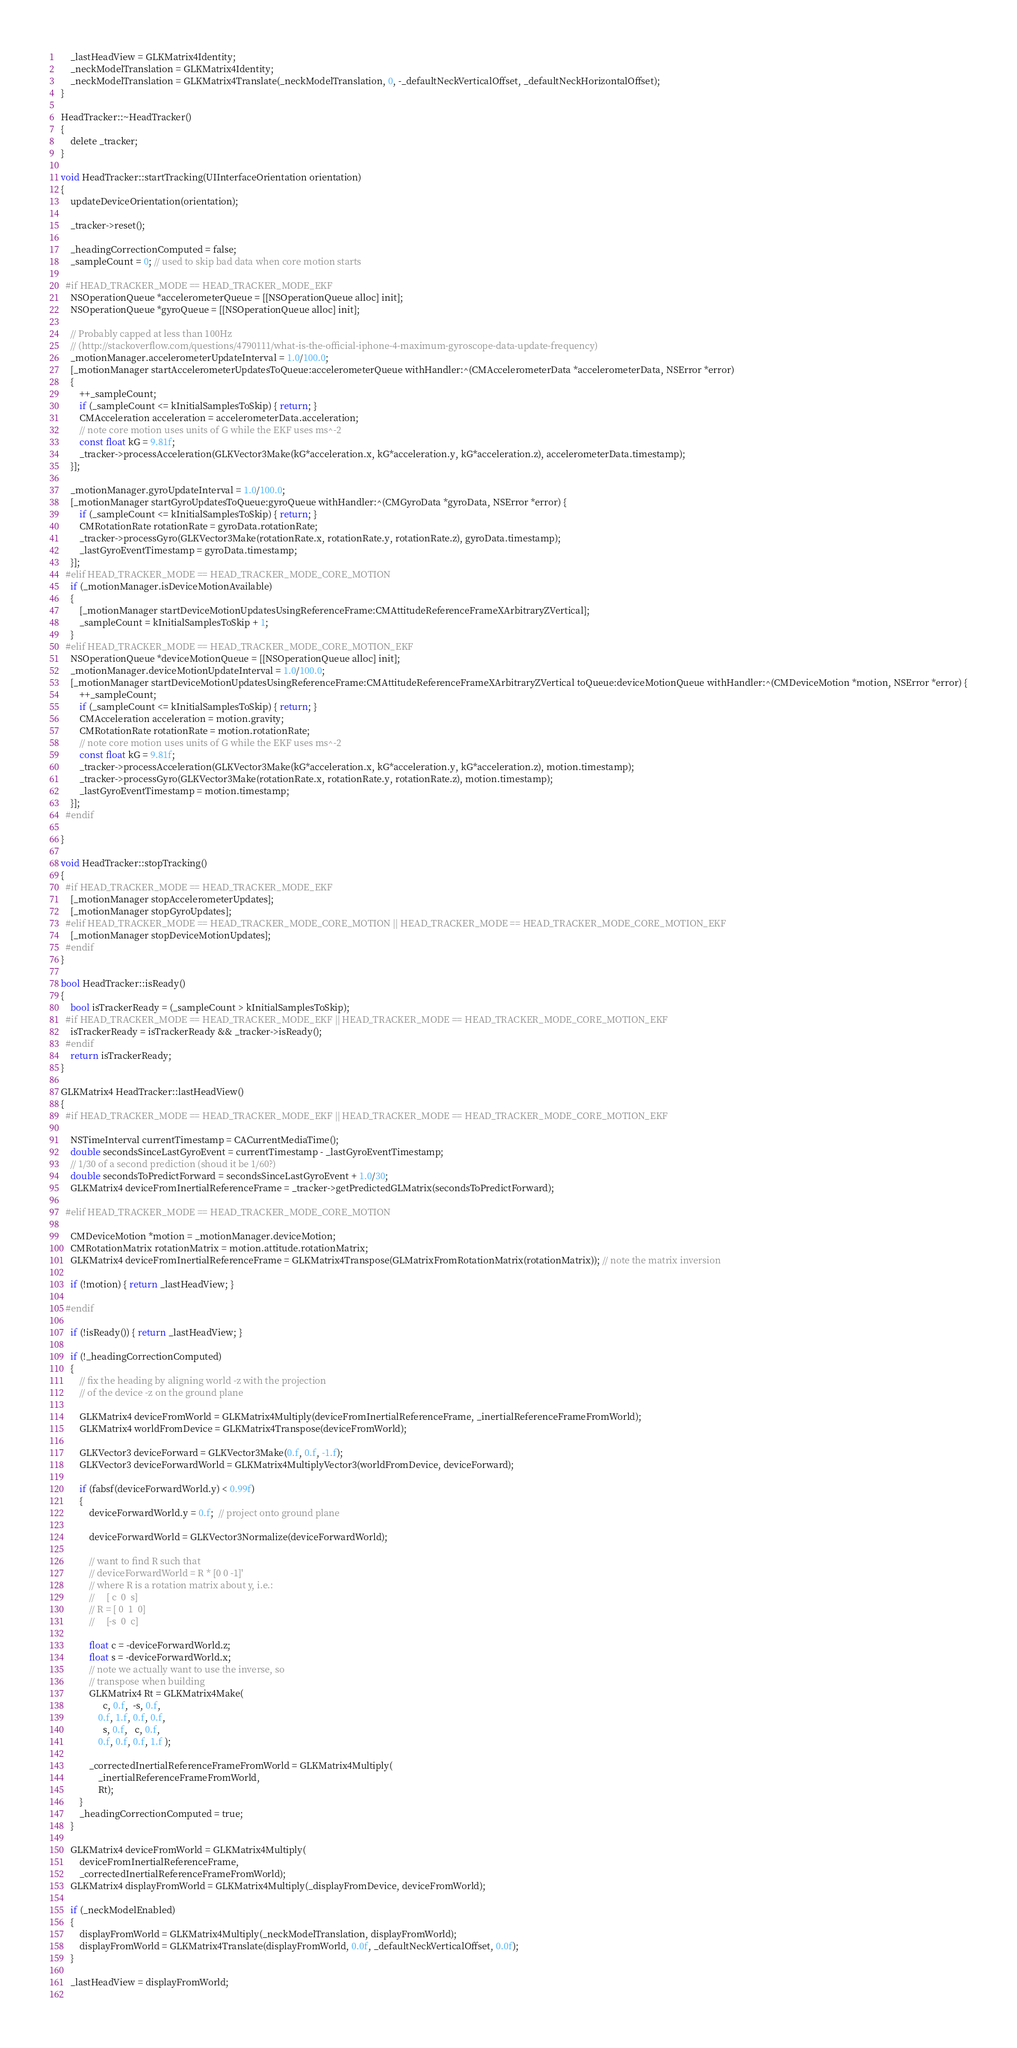Convert code to text. <code><loc_0><loc_0><loc_500><loc_500><_ObjectiveC_>    _lastHeadView = GLKMatrix4Identity;
    _neckModelTranslation = GLKMatrix4Identity;
    _neckModelTranslation = GLKMatrix4Translate(_neckModelTranslation, 0, -_defaultNeckVerticalOffset, _defaultNeckHorizontalOffset);
}

HeadTracker::~HeadTracker()
{
    delete _tracker;
}

void HeadTracker::startTracking(UIInterfaceOrientation orientation)
{
    updateDeviceOrientation(orientation);
    
    _tracker->reset();
    
    _headingCorrectionComputed = false;
    _sampleCount = 0; // used to skip bad data when core motion starts
    
  #if HEAD_TRACKER_MODE == HEAD_TRACKER_MODE_EKF
    NSOperationQueue *accelerometerQueue = [[NSOperationQueue alloc] init];
    NSOperationQueue *gyroQueue = [[NSOperationQueue alloc] init];
    
    // Probably capped at less than 100Hz
    // (http://stackoverflow.com/questions/4790111/what-is-the-official-iphone-4-maximum-gyroscope-data-update-frequency)
    _motionManager.accelerometerUpdateInterval = 1.0/100.0;
    [_motionManager startAccelerometerUpdatesToQueue:accelerometerQueue withHandler:^(CMAccelerometerData *accelerometerData, NSError *error)
    {
        ++_sampleCount;
        if (_sampleCount <= kInitialSamplesToSkip) { return; }
        CMAcceleration acceleration = accelerometerData.acceleration;
        // note core motion uses units of G while the EKF uses ms^-2
        const float kG = 9.81f;
        _tracker->processAcceleration(GLKVector3Make(kG*acceleration.x, kG*acceleration.y, kG*acceleration.z), accelerometerData.timestamp);
    }];
    
    _motionManager.gyroUpdateInterval = 1.0/100.0;
    [_motionManager startGyroUpdatesToQueue:gyroQueue withHandler:^(CMGyroData *gyroData, NSError *error) {
        if (_sampleCount <= kInitialSamplesToSkip) { return; }
        CMRotationRate rotationRate = gyroData.rotationRate;
        _tracker->processGyro(GLKVector3Make(rotationRate.x, rotationRate.y, rotationRate.z), gyroData.timestamp);
        _lastGyroEventTimestamp = gyroData.timestamp;
    }];
  #elif HEAD_TRACKER_MODE == HEAD_TRACKER_MODE_CORE_MOTION
    if (_motionManager.isDeviceMotionAvailable)
    {
        [_motionManager startDeviceMotionUpdatesUsingReferenceFrame:CMAttitudeReferenceFrameXArbitraryZVertical];
        _sampleCount = kInitialSamplesToSkip + 1;
    }
  #elif HEAD_TRACKER_MODE == HEAD_TRACKER_MODE_CORE_MOTION_EKF
    NSOperationQueue *deviceMotionQueue = [[NSOperationQueue alloc] init];
    _motionManager.deviceMotionUpdateInterval = 1.0/100.0;
    [_motionManager startDeviceMotionUpdatesUsingReferenceFrame:CMAttitudeReferenceFrameXArbitraryZVertical toQueue:deviceMotionQueue withHandler:^(CMDeviceMotion *motion, NSError *error) {
        ++_sampleCount;
        if (_sampleCount <= kInitialSamplesToSkip) { return; }
        CMAcceleration acceleration = motion.gravity;
        CMRotationRate rotationRate = motion.rotationRate;
        // note core motion uses units of G while the EKF uses ms^-2
        const float kG = 9.81f;
        _tracker->processAcceleration(GLKVector3Make(kG*acceleration.x, kG*acceleration.y, kG*acceleration.z), motion.timestamp);
        _tracker->processGyro(GLKVector3Make(rotationRate.x, rotationRate.y, rotationRate.z), motion.timestamp);
        _lastGyroEventTimestamp = motion.timestamp;
    }];
  #endif
    
}

void HeadTracker::stopTracking()
{
  #if HEAD_TRACKER_MODE == HEAD_TRACKER_MODE_EKF
    [_motionManager stopAccelerometerUpdates];
    [_motionManager stopGyroUpdates];
  #elif HEAD_TRACKER_MODE == HEAD_TRACKER_MODE_CORE_MOTION || HEAD_TRACKER_MODE == HEAD_TRACKER_MODE_CORE_MOTION_EKF
    [_motionManager stopDeviceMotionUpdates];
  #endif
}

bool HeadTracker::isReady()
{
    bool isTrackerReady = (_sampleCount > kInitialSamplesToSkip);
  #if HEAD_TRACKER_MODE == HEAD_TRACKER_MODE_EKF || HEAD_TRACKER_MODE == HEAD_TRACKER_MODE_CORE_MOTION_EKF
    isTrackerReady = isTrackerReady && _tracker->isReady();
  #endif
    return isTrackerReady;
}

GLKMatrix4 HeadTracker::lastHeadView()
{
  #if HEAD_TRACKER_MODE == HEAD_TRACKER_MODE_EKF || HEAD_TRACKER_MODE == HEAD_TRACKER_MODE_CORE_MOTION_EKF
    
    NSTimeInterval currentTimestamp = CACurrentMediaTime();
    double secondsSinceLastGyroEvent = currentTimestamp - _lastGyroEventTimestamp;
    // 1/30 of a second prediction (shoud it be 1/60?)
    double secondsToPredictForward = secondsSinceLastGyroEvent + 1.0/30;
    GLKMatrix4 deviceFromInertialReferenceFrame = _tracker->getPredictedGLMatrix(secondsToPredictForward);
    
  #elif HEAD_TRACKER_MODE == HEAD_TRACKER_MODE_CORE_MOTION
    
    CMDeviceMotion *motion = _motionManager.deviceMotion;
    CMRotationMatrix rotationMatrix = motion.attitude.rotationMatrix;
    GLKMatrix4 deviceFromInertialReferenceFrame = GLKMatrix4Transpose(GLMatrixFromRotationMatrix(rotationMatrix)); // note the matrix inversion
    
    if (!motion) { return _lastHeadView; }
    
  #endif
  
    if (!isReady()) { return _lastHeadView; }

    if (!_headingCorrectionComputed)
    {
        // fix the heading by aligning world -z with the projection 
        // of the device -z on the ground plane
        
        GLKMatrix4 deviceFromWorld = GLKMatrix4Multiply(deviceFromInertialReferenceFrame, _inertialReferenceFrameFromWorld);
        GLKMatrix4 worldFromDevice = GLKMatrix4Transpose(deviceFromWorld);
        
        GLKVector3 deviceForward = GLKVector3Make(0.f, 0.f, -1.f);
        GLKVector3 deviceForwardWorld = GLKMatrix4MultiplyVector3(worldFromDevice, deviceForward);
        
        if (fabsf(deviceForwardWorld.y) < 0.99f)
        {
            deviceForwardWorld.y = 0.f;  // project onto ground plane
            
            deviceForwardWorld = GLKVector3Normalize(deviceForwardWorld);
            
            // want to find R such that
            // deviceForwardWorld = R * [0 0 -1]'
            // where R is a rotation matrix about y, i.e.:
            //     [ c  0  s]
            // R = [ 0  1  0]
            //     [-s  0  c]
            
            float c = -deviceForwardWorld.z;
            float s = -deviceForwardWorld.x;
            // note we actually want to use the inverse, so
            // transpose when building
            GLKMatrix4 Rt = GLKMatrix4Make(
                  c, 0.f,  -s, 0.f,
                0.f, 1.f, 0.f, 0.f,
                  s, 0.f,   c, 0.f,
                0.f, 0.f, 0.f, 1.f );
            
            _correctedInertialReferenceFrameFromWorld = GLKMatrix4Multiply(
                _inertialReferenceFrameFromWorld,
                Rt);
        }
        _headingCorrectionComputed = true;
    }
    
    GLKMatrix4 deviceFromWorld = GLKMatrix4Multiply(
        deviceFromInertialReferenceFrame,
        _correctedInertialReferenceFrameFromWorld);
    GLKMatrix4 displayFromWorld = GLKMatrix4Multiply(_displayFromDevice, deviceFromWorld);
    
    if (_neckModelEnabled)
    {
        displayFromWorld = GLKMatrix4Multiply(_neckModelTranslation, displayFromWorld);
        displayFromWorld = GLKMatrix4Translate(displayFromWorld, 0.0f, _defaultNeckVerticalOffset, 0.0f);
    }
    
    _lastHeadView = displayFromWorld;
    </code> 